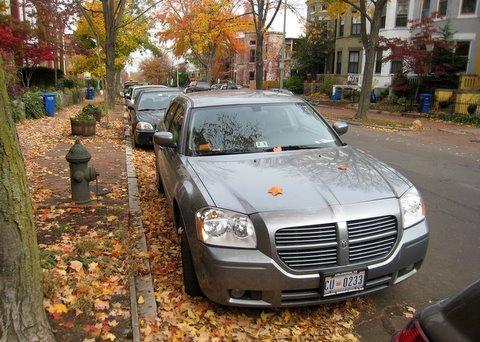How many cars are visible?
Give a very brief answer. 2. How many men in the picture are wearing sunglasses?
Give a very brief answer. 0. 